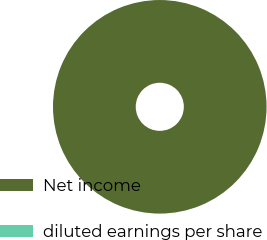Convert chart. <chart><loc_0><loc_0><loc_500><loc_500><pie_chart><fcel>Net income<fcel>diluted earnings per share<nl><fcel>100.0%<fcel>0.0%<nl></chart> 